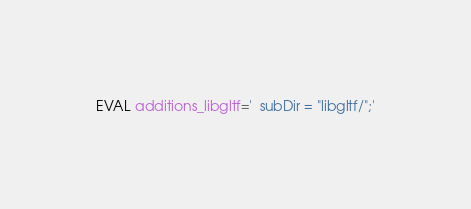<code> <loc_0><loc_0><loc_500><loc_500><_Bash_>EVAL additions_libgltf='  subDir = "libgltf/";'
</code> 